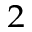Convert formula to latex. <formula><loc_0><loc_0><loc_500><loc_500>^ { 2 }</formula> 